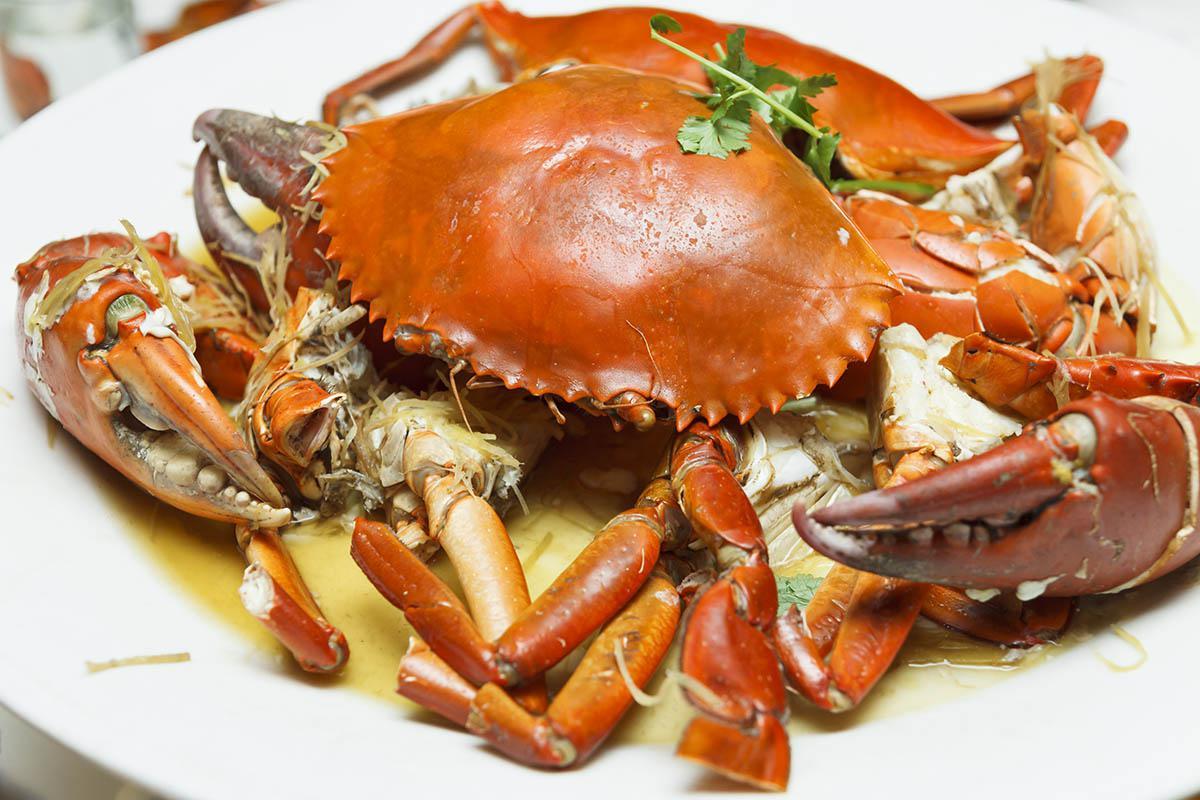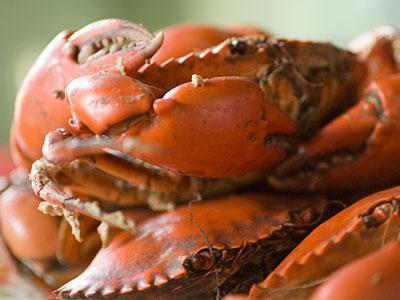The first image is the image on the left, the second image is the image on the right. Analyze the images presented: Is the assertion "One image contains a single red-orange crab with an intact red-orange shell and claws, and the other image includes multiple crabs on a white container surface." valid? Answer yes or no. No. The first image is the image on the left, the second image is the image on the right. Considering the images on both sides, is "At least one of the crabs has black tipped pincers." valid? Answer yes or no. No. 